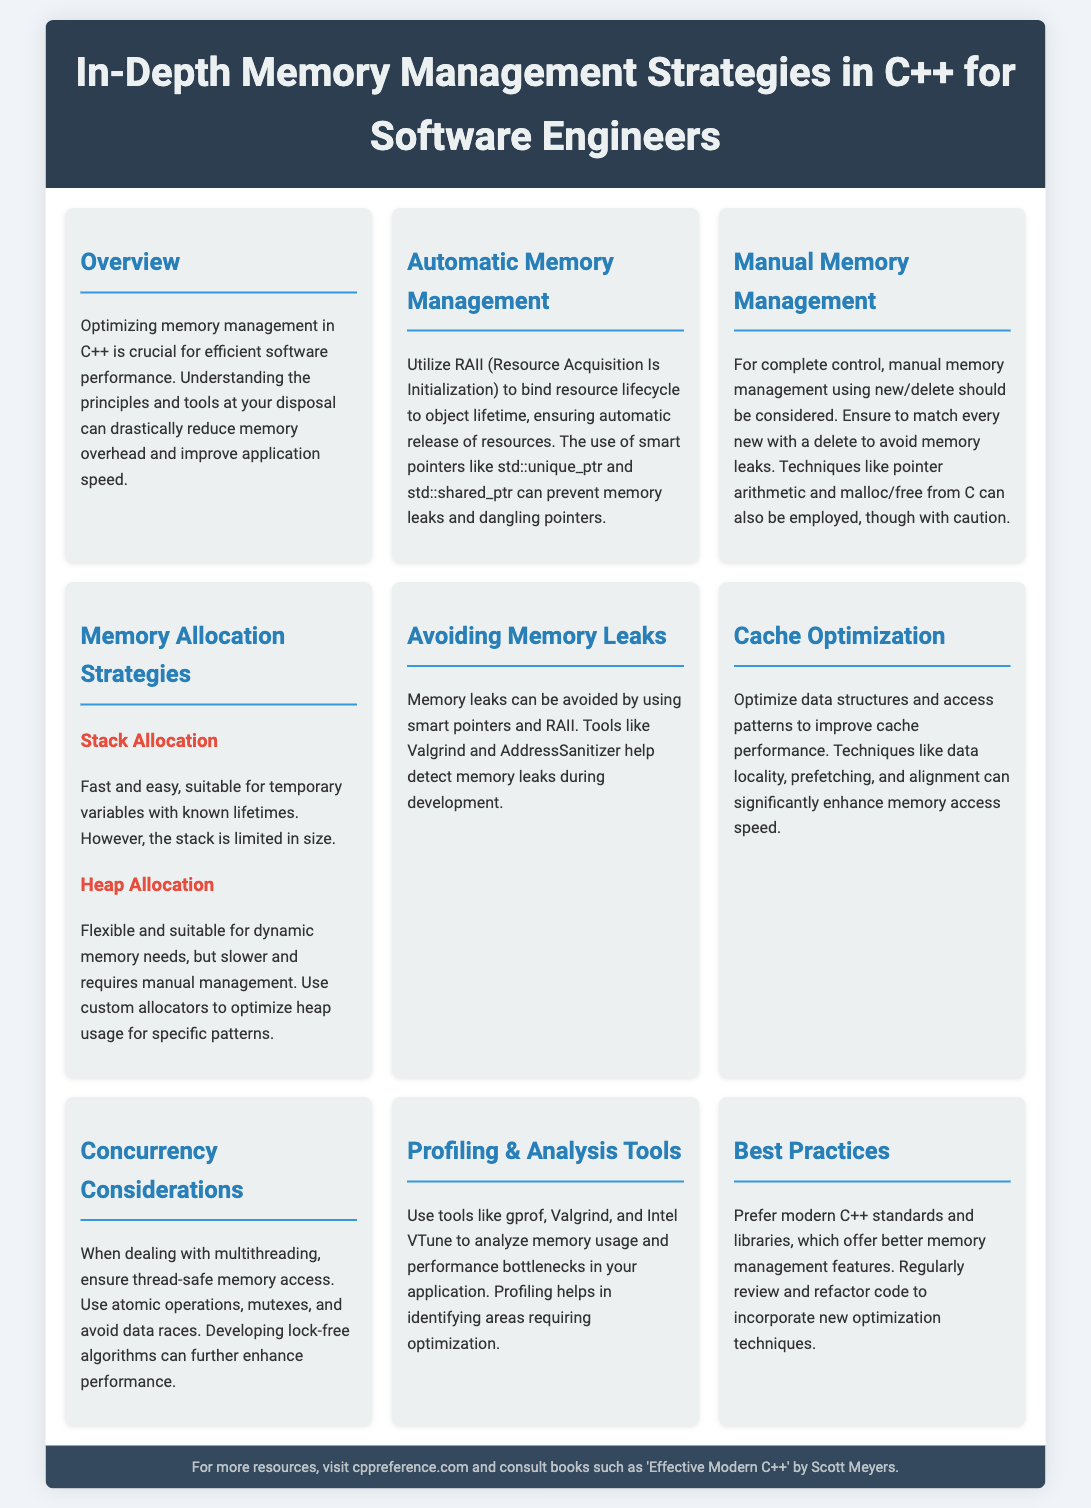what does RAII stand for? RAII is defined in the document as Resource Acquisition Is Initialization.
Answer: Resource Acquisition Is Initialization which tools help detect memory leaks? The document lists tools such as Valgrind and AddressSanitizer for detecting memory leaks.
Answer: Valgrind and AddressSanitizer what is the benefit of using smart pointers? The document states that smart pointers can prevent memory leaks and dangling pointers.
Answer: Prevent memory leaks and dangling pointers what memory allocation strategy is fast and easy? The document mentions stack allocation as fast and easy for temporary variables.
Answer: Stack allocation which optimization technique enhances memory access speed? The document describes several techniques, with data locality mentioned as a key optimization technique.
Answer: Data locality how can multithreading affect memory access? The section on Concurrency Considerations discusses the need for thread-safe memory access in multithreading scenarios.
Answer: Thread-safe memory access which book is recommended in the footer? The document recommends 'Effective Modern C++' by Scott Meyers in the footer.
Answer: Effective Modern C++ how often should you review and refactor code? The document implies regular reviews and refactoring to incorporate new optimization techniques.
Answer: Regularly 